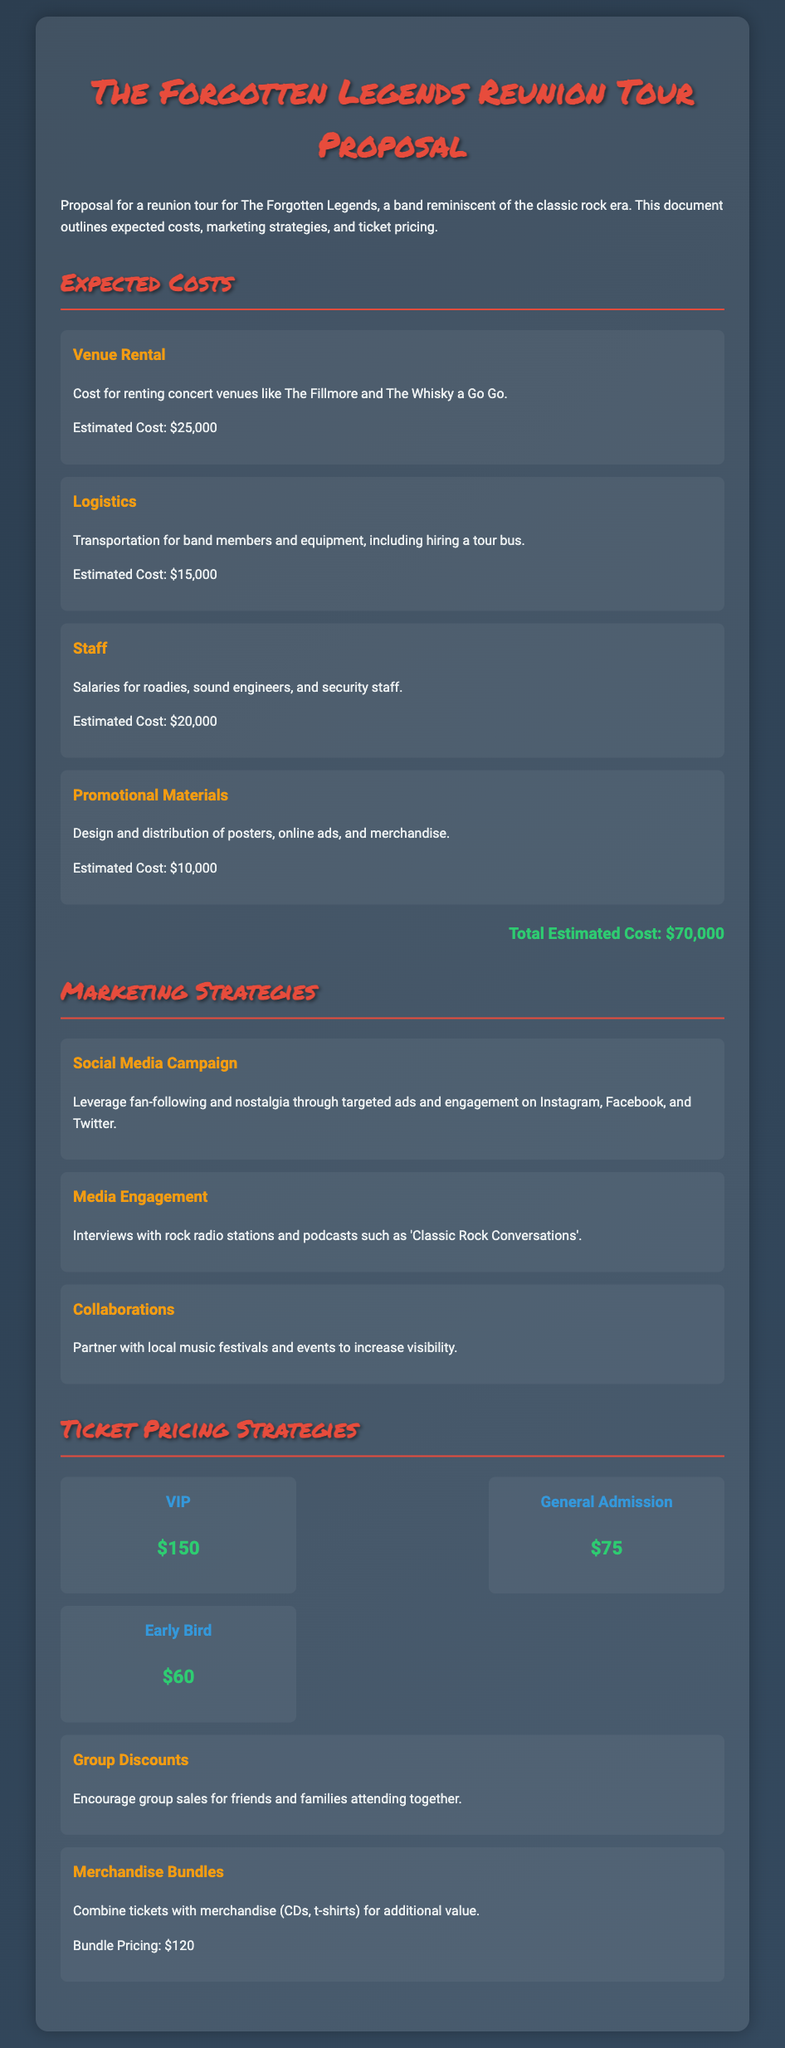What is the total estimated cost? The total estimated cost is provided in the document and is the sum of all the expected costs listed.
Answer: $70,000 What is the cost of venue rental? The document specifies the cost associated with renting concert venues as one of the expected costs.
Answer: $25,000 Which social media platforms are mentioned for the marketing campaign? The document lists Instagram, Facebook, and Twitter as the platforms to leverage for the marketing strategies.
Answer: Instagram, Facebook, Twitter What type of ticket is priced at $150? The document categorizes tickets into tiers, and VIP tickets have the highest price listed.
Answer: VIP What is the estimated cost for promotional materials? One of the costs outlined in the document is for promotional materials, detailing its significance to the tour.
Answer: $10,000 Which strategy involves partnering with local festivals? The document refers to a marketing strategy that includes working with local music festivals for increased visibility.
Answer: Collaborations What is the price of the Early Bird ticket? The document provides a specific price for the Early Bird ticket in the ticket pricing section.
Answer: $60 What does the merchandise bundle pricing offer? The document mentions a combined offer that includes tickets and merchandise, outlining a specific price for this bundle.
Answer: $120 What is the estimated logistics cost for the tour? The document provides details on logistics costs, reflecting the different expenses involved in organizing the tour.
Answer: $15,000 